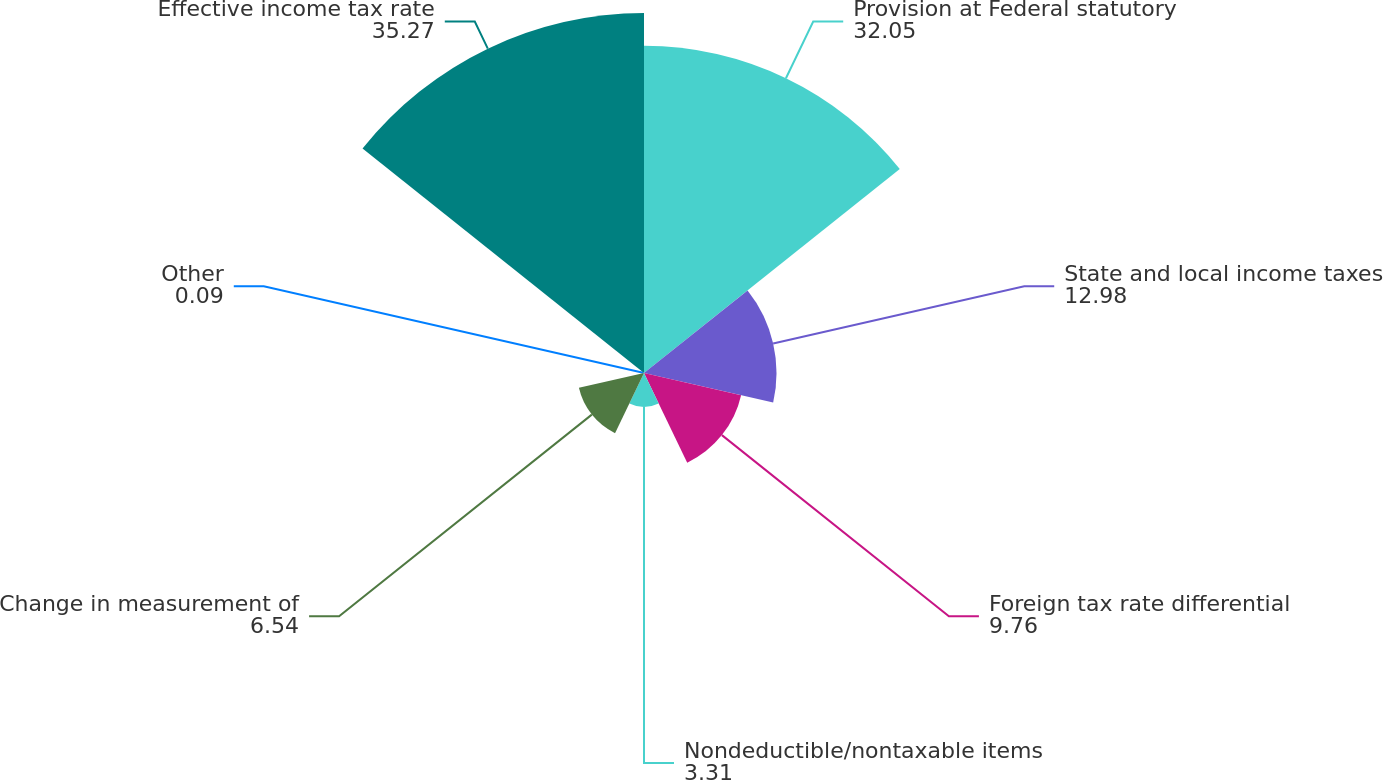Convert chart. <chart><loc_0><loc_0><loc_500><loc_500><pie_chart><fcel>Provision at Federal statutory<fcel>State and local income taxes<fcel>Foreign tax rate differential<fcel>Nondeductible/nontaxable items<fcel>Change in measurement of<fcel>Other<fcel>Effective income tax rate<nl><fcel>32.05%<fcel>12.98%<fcel>9.76%<fcel>3.31%<fcel>6.54%<fcel>0.09%<fcel>35.27%<nl></chart> 